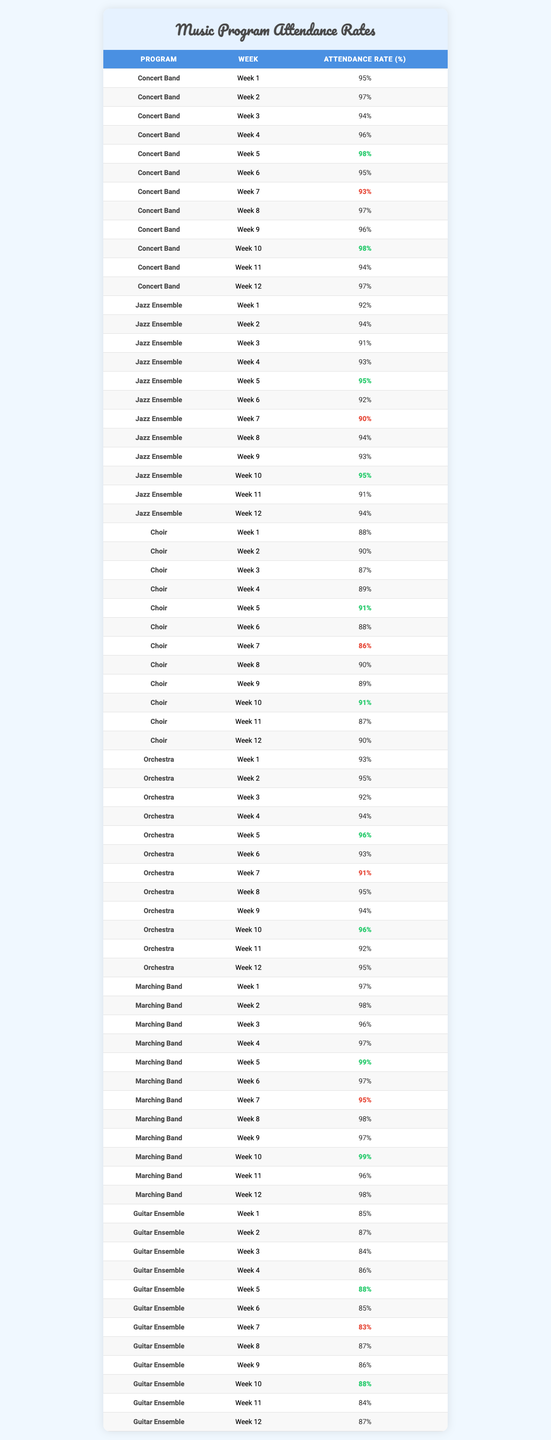What program had the highest attendance in week 5? Looking at the attendance rates for week 5, Concert Band had an attendance rate of 98%, Jazz Ensemble had 95%, Choir had 91%, Orchestra had 96%, Marching Band had 99%, and Guitar Ensemble had 88%. The highest rate is 99%, which corresponds to Marching Band.
Answer: Marching Band What is the average attendance rate of the Jazz Ensemble over the semester? The attendance rates for the Jazz Ensemble are as follows: 92, 94, 91, 93, 95, 92, 90, 94, 93, 95, 91, 94. Adding these values gives 1,114, and there are 12 weeks of attendance, so the average is 1,114 divided by 12, which is approximately 92.83.
Answer: 92.83 Did any program have an attendance rate below 90% in any week? Checking each program for weekly attendance, Choir had rates of 88% in week 1, 87% in week 3, and 86% in week 7, which are all below 90%. Therefore, the answer is yes.
Answer: Yes Which program had the most consistent attendance rates over the semester? To evaluate consistency, we can look at the range of attendance rates for each program. Concert Band had rates from 93% to 98%, Jazz Ensemble from 90% to 95%, Choir from 86% to 91%, Orchestra from 91% to 96%, Marching Band from 95% to 99%, and Guitar Ensemble from 83% to 88%. The program with the smallest range is Concert Band (98 - 93 = 5), indicating it had the most consistent attendance.
Answer: Concert Band What is the percentage difference in attendance rates between the highest and lowest weeks for the Orchestra? For the Orchestra, the highest attendance was 96% in weeks 5 and 10, and the lowest was 91% in week 7. The percentage difference is calculated as (96 - 91) / 91 * 100, which equals approximately 5.49%.
Answer: 5.49% 